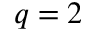Convert formula to latex. <formula><loc_0><loc_0><loc_500><loc_500>q = 2</formula> 